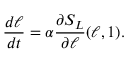Convert formula to latex. <formula><loc_0><loc_0><loc_500><loc_500>\frac { d \ell } { d t } = \alpha \frac { \partial S _ { L } } { \partial \ell } ( \ell , 1 ) .</formula> 